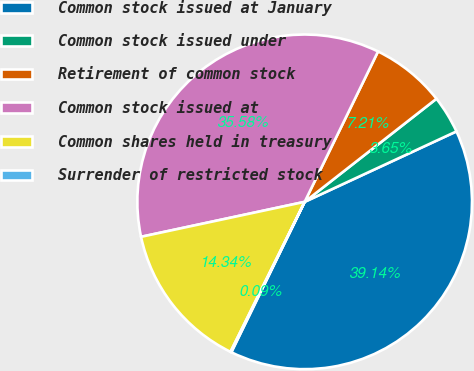Convert chart. <chart><loc_0><loc_0><loc_500><loc_500><pie_chart><fcel>Common stock issued at January<fcel>Common stock issued under<fcel>Retirement of common stock<fcel>Common stock issued at<fcel>Common shares held in treasury<fcel>Surrender of restricted stock<nl><fcel>39.14%<fcel>3.65%<fcel>7.21%<fcel>35.58%<fcel>14.34%<fcel>0.09%<nl></chart> 